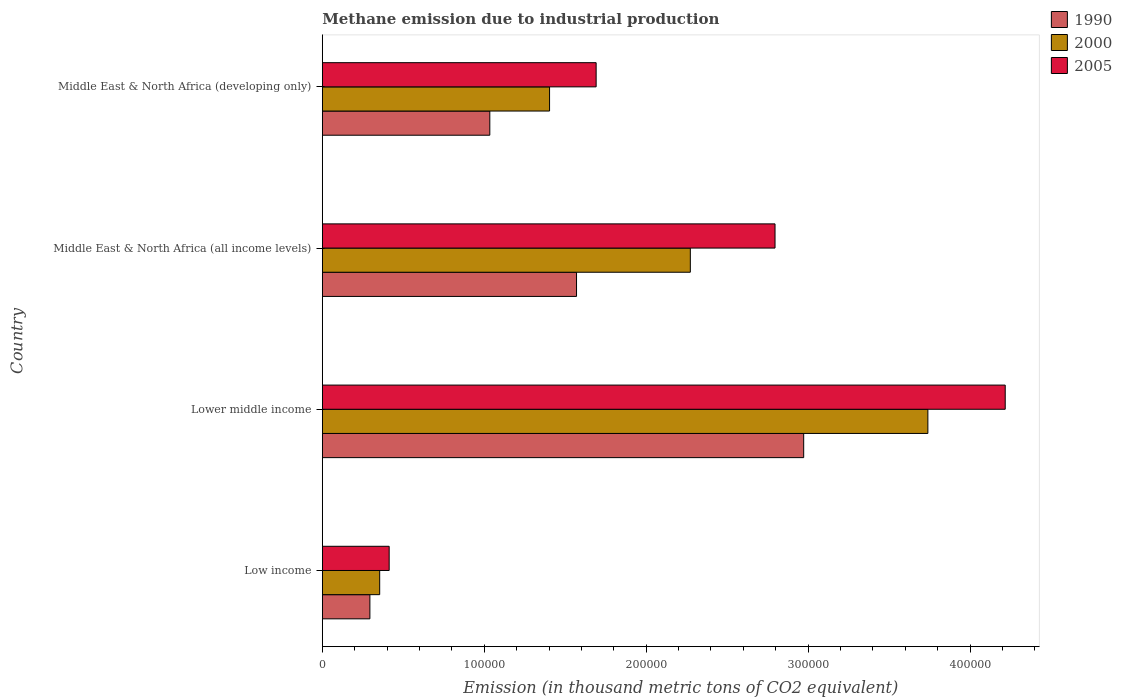How many groups of bars are there?
Offer a very short reply. 4. Are the number of bars per tick equal to the number of legend labels?
Give a very brief answer. Yes. Are the number of bars on each tick of the Y-axis equal?
Provide a short and direct response. Yes. How many bars are there on the 1st tick from the top?
Your response must be concise. 3. What is the amount of methane emitted in 2000 in Lower middle income?
Make the answer very short. 3.74e+05. Across all countries, what is the maximum amount of methane emitted in 2000?
Provide a succinct answer. 3.74e+05. Across all countries, what is the minimum amount of methane emitted in 2005?
Make the answer very short. 4.13e+04. In which country was the amount of methane emitted in 2000 maximum?
Give a very brief answer. Lower middle income. What is the total amount of methane emitted in 2000 in the graph?
Your answer should be compact. 7.77e+05. What is the difference between the amount of methane emitted in 2005 in Lower middle income and that in Middle East & North Africa (developing only)?
Provide a succinct answer. 2.53e+05. What is the difference between the amount of methane emitted in 2000 in Lower middle income and the amount of methane emitted in 1990 in Middle East & North Africa (developing only)?
Make the answer very short. 2.71e+05. What is the average amount of methane emitted in 2000 per country?
Your response must be concise. 1.94e+05. What is the difference between the amount of methane emitted in 1990 and amount of methane emitted in 2005 in Lower middle income?
Offer a very short reply. -1.24e+05. What is the ratio of the amount of methane emitted in 1990 in Middle East & North Africa (all income levels) to that in Middle East & North Africa (developing only)?
Your answer should be compact. 1.52. Is the amount of methane emitted in 1990 in Low income less than that in Middle East & North Africa (developing only)?
Give a very brief answer. Yes. Is the difference between the amount of methane emitted in 1990 in Lower middle income and Middle East & North Africa (developing only) greater than the difference between the amount of methane emitted in 2005 in Lower middle income and Middle East & North Africa (developing only)?
Your answer should be very brief. No. What is the difference between the highest and the second highest amount of methane emitted in 2000?
Your response must be concise. 1.47e+05. What is the difference between the highest and the lowest amount of methane emitted in 1990?
Your answer should be compact. 2.68e+05. In how many countries, is the amount of methane emitted in 2005 greater than the average amount of methane emitted in 2005 taken over all countries?
Make the answer very short. 2. Is the sum of the amount of methane emitted in 1990 in Middle East & North Africa (all income levels) and Middle East & North Africa (developing only) greater than the maximum amount of methane emitted in 2005 across all countries?
Keep it short and to the point. No. Is it the case that in every country, the sum of the amount of methane emitted in 1990 and amount of methane emitted in 2005 is greater than the amount of methane emitted in 2000?
Offer a very short reply. Yes. What is the difference between two consecutive major ticks on the X-axis?
Your answer should be compact. 1.00e+05. Are the values on the major ticks of X-axis written in scientific E-notation?
Keep it short and to the point. No. Does the graph contain any zero values?
Keep it short and to the point. No. Does the graph contain grids?
Your answer should be compact. No. How many legend labels are there?
Keep it short and to the point. 3. What is the title of the graph?
Your answer should be compact. Methane emission due to industrial production. What is the label or title of the X-axis?
Give a very brief answer. Emission (in thousand metric tons of CO2 equivalent). What is the Emission (in thousand metric tons of CO2 equivalent) of 1990 in Low income?
Provide a short and direct response. 2.94e+04. What is the Emission (in thousand metric tons of CO2 equivalent) in 2000 in Low income?
Provide a short and direct response. 3.54e+04. What is the Emission (in thousand metric tons of CO2 equivalent) in 2005 in Low income?
Provide a short and direct response. 4.13e+04. What is the Emission (in thousand metric tons of CO2 equivalent) in 1990 in Lower middle income?
Your answer should be compact. 2.97e+05. What is the Emission (in thousand metric tons of CO2 equivalent) in 2000 in Lower middle income?
Provide a short and direct response. 3.74e+05. What is the Emission (in thousand metric tons of CO2 equivalent) of 2005 in Lower middle income?
Provide a succinct answer. 4.22e+05. What is the Emission (in thousand metric tons of CO2 equivalent) of 1990 in Middle East & North Africa (all income levels)?
Make the answer very short. 1.57e+05. What is the Emission (in thousand metric tons of CO2 equivalent) of 2000 in Middle East & North Africa (all income levels)?
Ensure brevity in your answer.  2.27e+05. What is the Emission (in thousand metric tons of CO2 equivalent) in 2005 in Middle East & North Africa (all income levels)?
Your response must be concise. 2.80e+05. What is the Emission (in thousand metric tons of CO2 equivalent) in 1990 in Middle East & North Africa (developing only)?
Provide a succinct answer. 1.03e+05. What is the Emission (in thousand metric tons of CO2 equivalent) in 2000 in Middle East & North Africa (developing only)?
Your answer should be very brief. 1.40e+05. What is the Emission (in thousand metric tons of CO2 equivalent) in 2005 in Middle East & North Africa (developing only)?
Make the answer very short. 1.69e+05. Across all countries, what is the maximum Emission (in thousand metric tons of CO2 equivalent) in 1990?
Provide a succinct answer. 2.97e+05. Across all countries, what is the maximum Emission (in thousand metric tons of CO2 equivalent) of 2000?
Ensure brevity in your answer.  3.74e+05. Across all countries, what is the maximum Emission (in thousand metric tons of CO2 equivalent) in 2005?
Keep it short and to the point. 4.22e+05. Across all countries, what is the minimum Emission (in thousand metric tons of CO2 equivalent) of 1990?
Offer a terse response. 2.94e+04. Across all countries, what is the minimum Emission (in thousand metric tons of CO2 equivalent) of 2000?
Keep it short and to the point. 3.54e+04. Across all countries, what is the minimum Emission (in thousand metric tons of CO2 equivalent) of 2005?
Your response must be concise. 4.13e+04. What is the total Emission (in thousand metric tons of CO2 equivalent) of 1990 in the graph?
Provide a succinct answer. 5.87e+05. What is the total Emission (in thousand metric tons of CO2 equivalent) in 2000 in the graph?
Ensure brevity in your answer.  7.77e+05. What is the total Emission (in thousand metric tons of CO2 equivalent) in 2005 in the graph?
Provide a short and direct response. 9.12e+05. What is the difference between the Emission (in thousand metric tons of CO2 equivalent) of 1990 in Low income and that in Lower middle income?
Provide a short and direct response. -2.68e+05. What is the difference between the Emission (in thousand metric tons of CO2 equivalent) in 2000 in Low income and that in Lower middle income?
Give a very brief answer. -3.39e+05. What is the difference between the Emission (in thousand metric tons of CO2 equivalent) of 2005 in Low income and that in Lower middle income?
Your response must be concise. -3.80e+05. What is the difference between the Emission (in thousand metric tons of CO2 equivalent) of 1990 in Low income and that in Middle East & North Africa (all income levels)?
Ensure brevity in your answer.  -1.28e+05. What is the difference between the Emission (in thousand metric tons of CO2 equivalent) of 2000 in Low income and that in Middle East & North Africa (all income levels)?
Your answer should be compact. -1.92e+05. What is the difference between the Emission (in thousand metric tons of CO2 equivalent) in 2005 in Low income and that in Middle East & North Africa (all income levels)?
Provide a short and direct response. -2.38e+05. What is the difference between the Emission (in thousand metric tons of CO2 equivalent) of 1990 in Low income and that in Middle East & North Africa (developing only)?
Your answer should be very brief. -7.41e+04. What is the difference between the Emission (in thousand metric tons of CO2 equivalent) of 2000 in Low income and that in Middle East & North Africa (developing only)?
Provide a succinct answer. -1.05e+05. What is the difference between the Emission (in thousand metric tons of CO2 equivalent) in 2005 in Low income and that in Middle East & North Africa (developing only)?
Offer a very short reply. -1.28e+05. What is the difference between the Emission (in thousand metric tons of CO2 equivalent) of 1990 in Lower middle income and that in Middle East & North Africa (all income levels)?
Give a very brief answer. 1.40e+05. What is the difference between the Emission (in thousand metric tons of CO2 equivalent) of 2000 in Lower middle income and that in Middle East & North Africa (all income levels)?
Your answer should be compact. 1.47e+05. What is the difference between the Emission (in thousand metric tons of CO2 equivalent) in 2005 in Lower middle income and that in Middle East & North Africa (all income levels)?
Your response must be concise. 1.42e+05. What is the difference between the Emission (in thousand metric tons of CO2 equivalent) of 1990 in Lower middle income and that in Middle East & North Africa (developing only)?
Ensure brevity in your answer.  1.94e+05. What is the difference between the Emission (in thousand metric tons of CO2 equivalent) in 2000 in Lower middle income and that in Middle East & North Africa (developing only)?
Ensure brevity in your answer.  2.34e+05. What is the difference between the Emission (in thousand metric tons of CO2 equivalent) in 2005 in Lower middle income and that in Middle East & North Africa (developing only)?
Provide a succinct answer. 2.53e+05. What is the difference between the Emission (in thousand metric tons of CO2 equivalent) of 1990 in Middle East & North Africa (all income levels) and that in Middle East & North Africa (developing only)?
Provide a short and direct response. 5.36e+04. What is the difference between the Emission (in thousand metric tons of CO2 equivalent) in 2000 in Middle East & North Africa (all income levels) and that in Middle East & North Africa (developing only)?
Offer a terse response. 8.69e+04. What is the difference between the Emission (in thousand metric tons of CO2 equivalent) in 2005 in Middle East & North Africa (all income levels) and that in Middle East & North Africa (developing only)?
Provide a succinct answer. 1.10e+05. What is the difference between the Emission (in thousand metric tons of CO2 equivalent) in 1990 in Low income and the Emission (in thousand metric tons of CO2 equivalent) in 2000 in Lower middle income?
Provide a short and direct response. -3.45e+05. What is the difference between the Emission (in thousand metric tons of CO2 equivalent) of 1990 in Low income and the Emission (in thousand metric tons of CO2 equivalent) of 2005 in Lower middle income?
Your response must be concise. -3.92e+05. What is the difference between the Emission (in thousand metric tons of CO2 equivalent) in 2000 in Low income and the Emission (in thousand metric tons of CO2 equivalent) in 2005 in Lower middle income?
Your answer should be very brief. -3.86e+05. What is the difference between the Emission (in thousand metric tons of CO2 equivalent) of 1990 in Low income and the Emission (in thousand metric tons of CO2 equivalent) of 2000 in Middle East & North Africa (all income levels)?
Give a very brief answer. -1.98e+05. What is the difference between the Emission (in thousand metric tons of CO2 equivalent) of 1990 in Low income and the Emission (in thousand metric tons of CO2 equivalent) of 2005 in Middle East & North Africa (all income levels)?
Your answer should be very brief. -2.50e+05. What is the difference between the Emission (in thousand metric tons of CO2 equivalent) in 2000 in Low income and the Emission (in thousand metric tons of CO2 equivalent) in 2005 in Middle East & North Africa (all income levels)?
Make the answer very short. -2.44e+05. What is the difference between the Emission (in thousand metric tons of CO2 equivalent) in 1990 in Low income and the Emission (in thousand metric tons of CO2 equivalent) in 2000 in Middle East & North Africa (developing only)?
Your response must be concise. -1.11e+05. What is the difference between the Emission (in thousand metric tons of CO2 equivalent) of 1990 in Low income and the Emission (in thousand metric tons of CO2 equivalent) of 2005 in Middle East & North Africa (developing only)?
Keep it short and to the point. -1.40e+05. What is the difference between the Emission (in thousand metric tons of CO2 equivalent) of 2000 in Low income and the Emission (in thousand metric tons of CO2 equivalent) of 2005 in Middle East & North Africa (developing only)?
Ensure brevity in your answer.  -1.34e+05. What is the difference between the Emission (in thousand metric tons of CO2 equivalent) of 1990 in Lower middle income and the Emission (in thousand metric tons of CO2 equivalent) of 2000 in Middle East & North Africa (all income levels)?
Provide a succinct answer. 7.00e+04. What is the difference between the Emission (in thousand metric tons of CO2 equivalent) of 1990 in Lower middle income and the Emission (in thousand metric tons of CO2 equivalent) of 2005 in Middle East & North Africa (all income levels)?
Your answer should be compact. 1.77e+04. What is the difference between the Emission (in thousand metric tons of CO2 equivalent) in 2000 in Lower middle income and the Emission (in thousand metric tons of CO2 equivalent) in 2005 in Middle East & North Africa (all income levels)?
Ensure brevity in your answer.  9.44e+04. What is the difference between the Emission (in thousand metric tons of CO2 equivalent) of 1990 in Lower middle income and the Emission (in thousand metric tons of CO2 equivalent) of 2000 in Middle East & North Africa (developing only)?
Provide a short and direct response. 1.57e+05. What is the difference between the Emission (in thousand metric tons of CO2 equivalent) in 1990 in Lower middle income and the Emission (in thousand metric tons of CO2 equivalent) in 2005 in Middle East & North Africa (developing only)?
Offer a terse response. 1.28e+05. What is the difference between the Emission (in thousand metric tons of CO2 equivalent) in 2000 in Lower middle income and the Emission (in thousand metric tons of CO2 equivalent) in 2005 in Middle East & North Africa (developing only)?
Offer a terse response. 2.05e+05. What is the difference between the Emission (in thousand metric tons of CO2 equivalent) of 1990 in Middle East & North Africa (all income levels) and the Emission (in thousand metric tons of CO2 equivalent) of 2000 in Middle East & North Africa (developing only)?
Provide a short and direct response. 1.67e+04. What is the difference between the Emission (in thousand metric tons of CO2 equivalent) in 1990 in Middle East & North Africa (all income levels) and the Emission (in thousand metric tons of CO2 equivalent) in 2005 in Middle East & North Africa (developing only)?
Provide a succinct answer. -1.21e+04. What is the difference between the Emission (in thousand metric tons of CO2 equivalent) in 2000 in Middle East & North Africa (all income levels) and the Emission (in thousand metric tons of CO2 equivalent) in 2005 in Middle East & North Africa (developing only)?
Your answer should be compact. 5.82e+04. What is the average Emission (in thousand metric tons of CO2 equivalent) of 1990 per country?
Offer a terse response. 1.47e+05. What is the average Emission (in thousand metric tons of CO2 equivalent) in 2000 per country?
Your answer should be compact. 1.94e+05. What is the average Emission (in thousand metric tons of CO2 equivalent) in 2005 per country?
Provide a short and direct response. 2.28e+05. What is the difference between the Emission (in thousand metric tons of CO2 equivalent) in 1990 and Emission (in thousand metric tons of CO2 equivalent) in 2000 in Low income?
Keep it short and to the point. -6052.7. What is the difference between the Emission (in thousand metric tons of CO2 equivalent) of 1990 and Emission (in thousand metric tons of CO2 equivalent) of 2005 in Low income?
Your answer should be compact. -1.19e+04. What is the difference between the Emission (in thousand metric tons of CO2 equivalent) of 2000 and Emission (in thousand metric tons of CO2 equivalent) of 2005 in Low income?
Your response must be concise. -5857.3. What is the difference between the Emission (in thousand metric tons of CO2 equivalent) in 1990 and Emission (in thousand metric tons of CO2 equivalent) in 2000 in Lower middle income?
Ensure brevity in your answer.  -7.67e+04. What is the difference between the Emission (in thousand metric tons of CO2 equivalent) in 1990 and Emission (in thousand metric tons of CO2 equivalent) in 2005 in Lower middle income?
Make the answer very short. -1.24e+05. What is the difference between the Emission (in thousand metric tons of CO2 equivalent) of 2000 and Emission (in thousand metric tons of CO2 equivalent) of 2005 in Lower middle income?
Give a very brief answer. -4.78e+04. What is the difference between the Emission (in thousand metric tons of CO2 equivalent) in 1990 and Emission (in thousand metric tons of CO2 equivalent) in 2000 in Middle East & North Africa (all income levels)?
Provide a short and direct response. -7.03e+04. What is the difference between the Emission (in thousand metric tons of CO2 equivalent) in 1990 and Emission (in thousand metric tons of CO2 equivalent) in 2005 in Middle East & North Africa (all income levels)?
Keep it short and to the point. -1.23e+05. What is the difference between the Emission (in thousand metric tons of CO2 equivalent) of 2000 and Emission (in thousand metric tons of CO2 equivalent) of 2005 in Middle East & North Africa (all income levels)?
Ensure brevity in your answer.  -5.23e+04. What is the difference between the Emission (in thousand metric tons of CO2 equivalent) of 1990 and Emission (in thousand metric tons of CO2 equivalent) of 2000 in Middle East & North Africa (developing only)?
Give a very brief answer. -3.69e+04. What is the difference between the Emission (in thousand metric tons of CO2 equivalent) of 1990 and Emission (in thousand metric tons of CO2 equivalent) of 2005 in Middle East & North Africa (developing only)?
Provide a short and direct response. -6.57e+04. What is the difference between the Emission (in thousand metric tons of CO2 equivalent) of 2000 and Emission (in thousand metric tons of CO2 equivalent) of 2005 in Middle East & North Africa (developing only)?
Ensure brevity in your answer.  -2.88e+04. What is the ratio of the Emission (in thousand metric tons of CO2 equivalent) of 1990 in Low income to that in Lower middle income?
Your answer should be compact. 0.1. What is the ratio of the Emission (in thousand metric tons of CO2 equivalent) in 2000 in Low income to that in Lower middle income?
Make the answer very short. 0.09. What is the ratio of the Emission (in thousand metric tons of CO2 equivalent) in 2005 in Low income to that in Lower middle income?
Give a very brief answer. 0.1. What is the ratio of the Emission (in thousand metric tons of CO2 equivalent) of 1990 in Low income to that in Middle East & North Africa (all income levels)?
Provide a succinct answer. 0.19. What is the ratio of the Emission (in thousand metric tons of CO2 equivalent) in 2000 in Low income to that in Middle East & North Africa (all income levels)?
Provide a succinct answer. 0.16. What is the ratio of the Emission (in thousand metric tons of CO2 equivalent) of 2005 in Low income to that in Middle East & North Africa (all income levels)?
Make the answer very short. 0.15. What is the ratio of the Emission (in thousand metric tons of CO2 equivalent) of 1990 in Low income to that in Middle East & North Africa (developing only)?
Your response must be concise. 0.28. What is the ratio of the Emission (in thousand metric tons of CO2 equivalent) in 2000 in Low income to that in Middle East & North Africa (developing only)?
Provide a succinct answer. 0.25. What is the ratio of the Emission (in thousand metric tons of CO2 equivalent) of 2005 in Low income to that in Middle East & North Africa (developing only)?
Provide a short and direct response. 0.24. What is the ratio of the Emission (in thousand metric tons of CO2 equivalent) in 1990 in Lower middle income to that in Middle East & North Africa (all income levels)?
Provide a succinct answer. 1.89. What is the ratio of the Emission (in thousand metric tons of CO2 equivalent) in 2000 in Lower middle income to that in Middle East & North Africa (all income levels)?
Make the answer very short. 1.65. What is the ratio of the Emission (in thousand metric tons of CO2 equivalent) of 2005 in Lower middle income to that in Middle East & North Africa (all income levels)?
Provide a succinct answer. 1.51. What is the ratio of the Emission (in thousand metric tons of CO2 equivalent) in 1990 in Lower middle income to that in Middle East & North Africa (developing only)?
Offer a very short reply. 2.87. What is the ratio of the Emission (in thousand metric tons of CO2 equivalent) in 2000 in Lower middle income to that in Middle East & North Africa (developing only)?
Give a very brief answer. 2.66. What is the ratio of the Emission (in thousand metric tons of CO2 equivalent) in 2005 in Lower middle income to that in Middle East & North Africa (developing only)?
Make the answer very short. 2.49. What is the ratio of the Emission (in thousand metric tons of CO2 equivalent) in 1990 in Middle East & North Africa (all income levels) to that in Middle East & North Africa (developing only)?
Provide a short and direct response. 1.52. What is the ratio of the Emission (in thousand metric tons of CO2 equivalent) of 2000 in Middle East & North Africa (all income levels) to that in Middle East & North Africa (developing only)?
Provide a succinct answer. 1.62. What is the ratio of the Emission (in thousand metric tons of CO2 equivalent) in 2005 in Middle East & North Africa (all income levels) to that in Middle East & North Africa (developing only)?
Keep it short and to the point. 1.65. What is the difference between the highest and the second highest Emission (in thousand metric tons of CO2 equivalent) in 1990?
Provide a succinct answer. 1.40e+05. What is the difference between the highest and the second highest Emission (in thousand metric tons of CO2 equivalent) of 2000?
Your response must be concise. 1.47e+05. What is the difference between the highest and the second highest Emission (in thousand metric tons of CO2 equivalent) in 2005?
Offer a terse response. 1.42e+05. What is the difference between the highest and the lowest Emission (in thousand metric tons of CO2 equivalent) of 1990?
Offer a very short reply. 2.68e+05. What is the difference between the highest and the lowest Emission (in thousand metric tons of CO2 equivalent) in 2000?
Your answer should be very brief. 3.39e+05. What is the difference between the highest and the lowest Emission (in thousand metric tons of CO2 equivalent) in 2005?
Make the answer very short. 3.80e+05. 